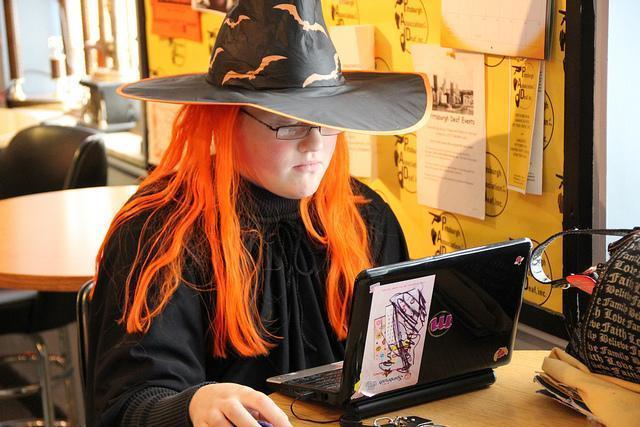How many chairs are in the picture?
Give a very brief answer. 2. How many dining tables are in the picture?
Give a very brief answer. 2. 